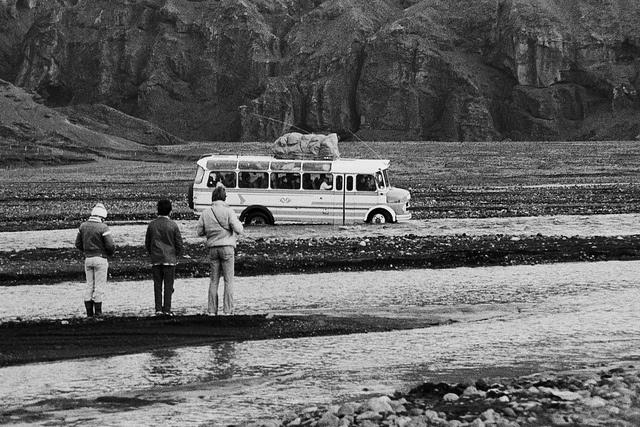Describe the objects in this image and their specific colors. I can see bus in gray, lightgray, darkgray, and black tones, people in gray, black, darkgray, and lightgray tones, people in gray, darkgray, black, and lightgray tones, people in gray, black, darkgray, and lightgray tones, and people in black and gray tones in this image. 